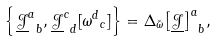Convert formula to latex. <formula><loc_0><loc_0><loc_500><loc_500>\left \{ { \underline { \mathcal { J } } ^ { a } } _ { b } , { \underline { \mathcal { J } } ^ { c } } _ { d } [ { \omega ^ { d } } _ { c } ] \right \} = \Delta _ { \tilde { \omega } } { \left [ \underline { \mathcal { J } } \right ] ^ { a } } _ { b } ,</formula> 